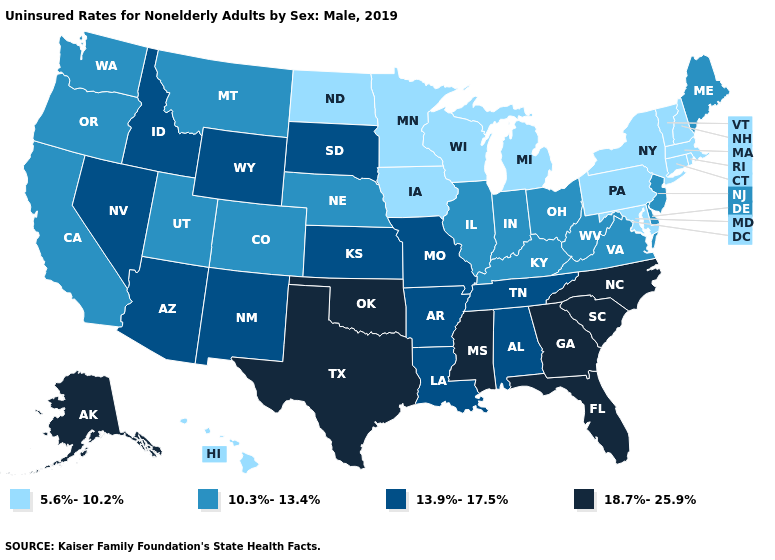What is the highest value in states that border Illinois?
Answer briefly. 13.9%-17.5%. What is the lowest value in the South?
Short answer required. 5.6%-10.2%. Name the states that have a value in the range 5.6%-10.2%?
Answer briefly. Connecticut, Hawaii, Iowa, Maryland, Massachusetts, Michigan, Minnesota, New Hampshire, New York, North Dakota, Pennsylvania, Rhode Island, Vermont, Wisconsin. Among the states that border New Mexico , does Oklahoma have the highest value?
Answer briefly. Yes. Name the states that have a value in the range 10.3%-13.4%?
Give a very brief answer. California, Colorado, Delaware, Illinois, Indiana, Kentucky, Maine, Montana, Nebraska, New Jersey, Ohio, Oregon, Utah, Virginia, Washington, West Virginia. What is the value of New York?
Keep it brief. 5.6%-10.2%. Name the states that have a value in the range 13.9%-17.5%?
Give a very brief answer. Alabama, Arizona, Arkansas, Idaho, Kansas, Louisiana, Missouri, Nevada, New Mexico, South Dakota, Tennessee, Wyoming. Which states have the highest value in the USA?
Quick response, please. Alaska, Florida, Georgia, Mississippi, North Carolina, Oklahoma, South Carolina, Texas. Which states hav the highest value in the MidWest?
Quick response, please. Kansas, Missouri, South Dakota. What is the lowest value in the USA?
Be succinct. 5.6%-10.2%. Which states have the lowest value in the MidWest?
Answer briefly. Iowa, Michigan, Minnesota, North Dakota, Wisconsin. Does the first symbol in the legend represent the smallest category?
Concise answer only. Yes. What is the lowest value in the USA?
Give a very brief answer. 5.6%-10.2%. What is the value of Colorado?
Answer briefly. 10.3%-13.4%. Name the states that have a value in the range 10.3%-13.4%?
Quick response, please. California, Colorado, Delaware, Illinois, Indiana, Kentucky, Maine, Montana, Nebraska, New Jersey, Ohio, Oregon, Utah, Virginia, Washington, West Virginia. 